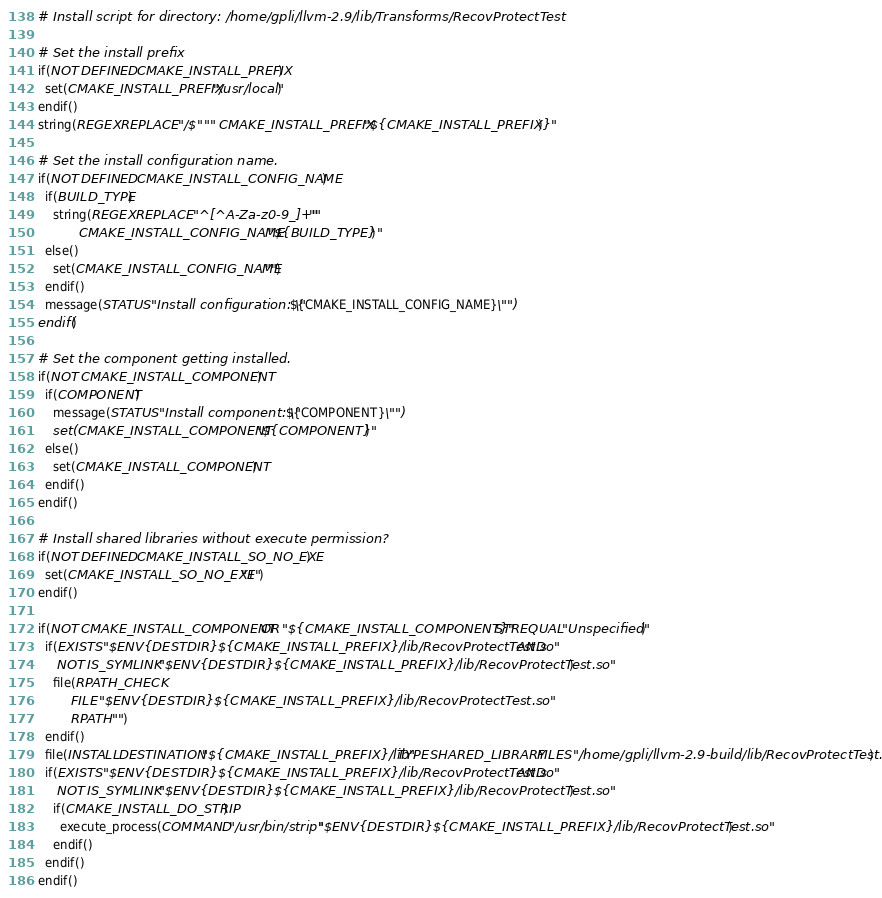Convert code to text. <code><loc_0><loc_0><loc_500><loc_500><_CMake_># Install script for directory: /home/gpli/llvm-2.9/lib/Transforms/RecovProtectTest

# Set the install prefix
if(NOT DEFINED CMAKE_INSTALL_PREFIX)
  set(CMAKE_INSTALL_PREFIX "/usr/local")
endif()
string(REGEX REPLACE "/$" "" CMAKE_INSTALL_PREFIX "${CMAKE_INSTALL_PREFIX}")

# Set the install configuration name.
if(NOT DEFINED CMAKE_INSTALL_CONFIG_NAME)
  if(BUILD_TYPE)
    string(REGEX REPLACE "^[^A-Za-z0-9_]+" ""
           CMAKE_INSTALL_CONFIG_NAME "${BUILD_TYPE}")
  else()
    set(CMAKE_INSTALL_CONFIG_NAME "")
  endif()
  message(STATUS "Install configuration: \"${CMAKE_INSTALL_CONFIG_NAME}\"")
endif()

# Set the component getting installed.
if(NOT CMAKE_INSTALL_COMPONENT)
  if(COMPONENT)
    message(STATUS "Install component: \"${COMPONENT}\"")
    set(CMAKE_INSTALL_COMPONENT "${COMPONENT}")
  else()
    set(CMAKE_INSTALL_COMPONENT)
  endif()
endif()

# Install shared libraries without execute permission?
if(NOT DEFINED CMAKE_INSTALL_SO_NO_EXE)
  set(CMAKE_INSTALL_SO_NO_EXE "1")
endif()

if(NOT CMAKE_INSTALL_COMPONENT OR "${CMAKE_INSTALL_COMPONENT}" STREQUAL "Unspecified")
  if(EXISTS "$ENV{DESTDIR}${CMAKE_INSTALL_PREFIX}/lib/RecovProtectTest.so" AND
     NOT IS_SYMLINK "$ENV{DESTDIR}${CMAKE_INSTALL_PREFIX}/lib/RecovProtectTest.so")
    file(RPATH_CHECK
         FILE "$ENV{DESTDIR}${CMAKE_INSTALL_PREFIX}/lib/RecovProtectTest.so"
         RPATH "")
  endif()
  file(INSTALL DESTINATION "${CMAKE_INSTALL_PREFIX}/lib" TYPE SHARED_LIBRARY FILES "/home/gpli/llvm-2.9-build/lib/RecovProtectTest.so")
  if(EXISTS "$ENV{DESTDIR}${CMAKE_INSTALL_PREFIX}/lib/RecovProtectTest.so" AND
     NOT IS_SYMLINK "$ENV{DESTDIR}${CMAKE_INSTALL_PREFIX}/lib/RecovProtectTest.so")
    if(CMAKE_INSTALL_DO_STRIP)
      execute_process(COMMAND "/usr/bin/strip" "$ENV{DESTDIR}${CMAKE_INSTALL_PREFIX}/lib/RecovProtectTest.so")
    endif()
  endif()
endif()

</code> 